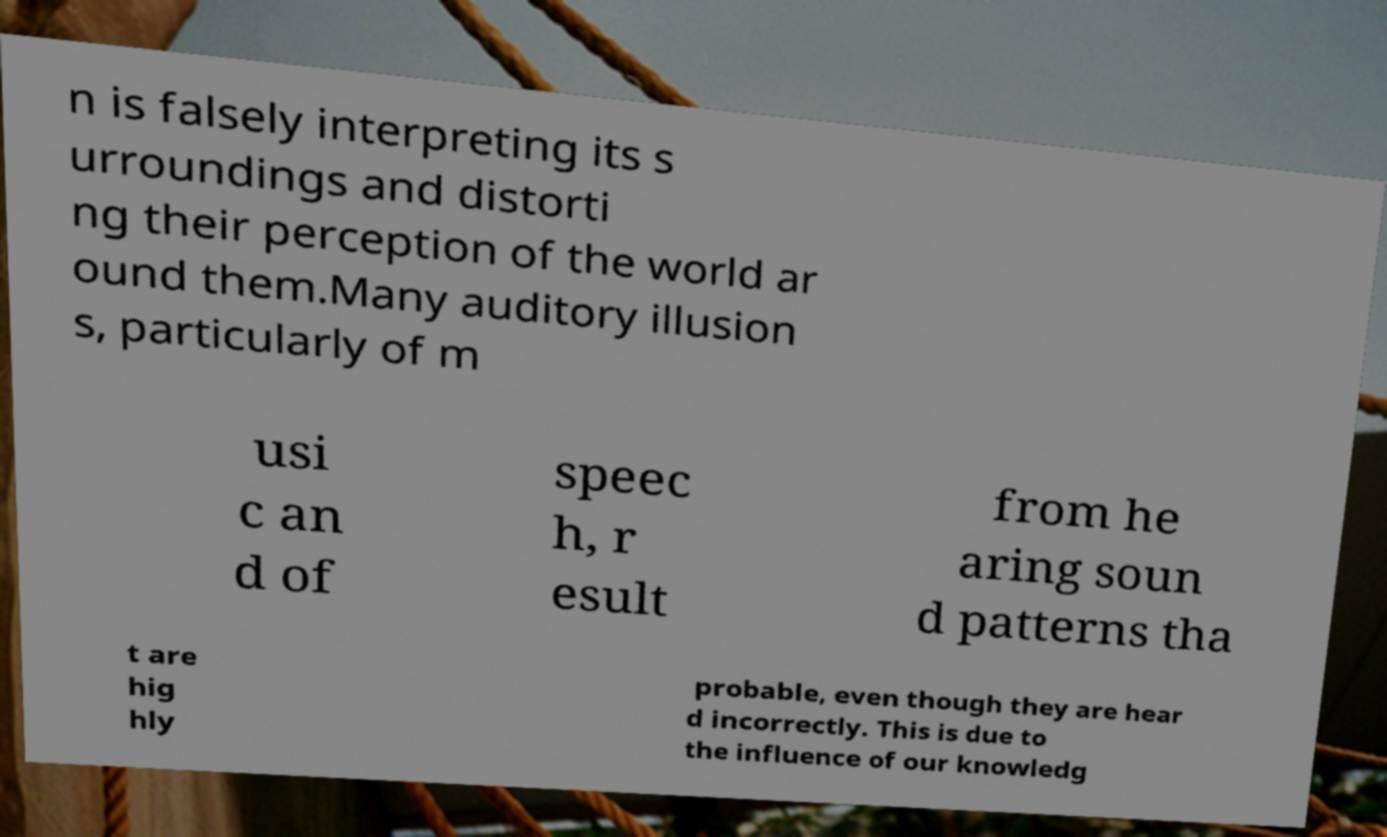Could you assist in decoding the text presented in this image and type it out clearly? n is falsely interpreting its s urroundings and distorti ng their perception of the world ar ound them.Many auditory illusion s, particularly of m usi c an d of speec h, r esult from he aring soun d patterns tha t are hig hly probable, even though they are hear d incorrectly. This is due to the influence of our knowledg 